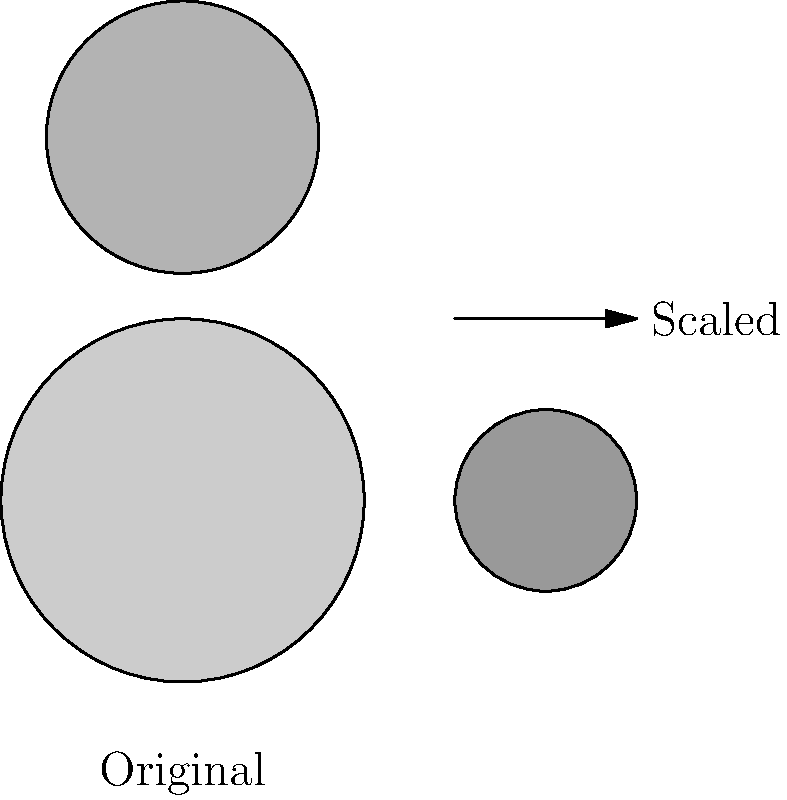In a redistricting proposal, the population demographics of a voting district are scaled by a factor of 0.5. If the original district had an area of 100 square miles and contained 50,000 voters, what would be the new voter density (voters per square mile) in the scaled district? To solve this problem, we need to follow these steps:

1. Calculate the new area of the scaled district:
   - Original area = 100 square miles
   - Scaling factor = 0.5
   - New area = $100 \times 0.5^2 = 100 \times 0.25 = 25$ square miles
   
   Note: When scaling a two-dimensional figure, we square the scaling factor.

2. Determine the new number of voters:
   - Original number of voters = 50,000
   - Scaling factor = 0.5
   - New number of voters = $50,000 \times 0.5 = 25,000$ voters

3. Calculate the new voter density:
   - Voter density = Number of voters ÷ Area
   - New voter density = $25,000 \div 25 = 1,000$ voters per square mile

4. Compare with the original voter density:
   - Original density = $50,000 \div 100 = 500$ voters per square mile
   - New density = 1,000 voters per square mile

The scaling has doubled the voter density, which could significantly impact the voting power of the district.
Answer: 1,000 voters per square mile 